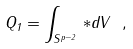Convert formula to latex. <formula><loc_0><loc_0><loc_500><loc_500>Q _ { 1 } = \int _ { S ^ { p - 2 } } \, * d V \ ,</formula> 